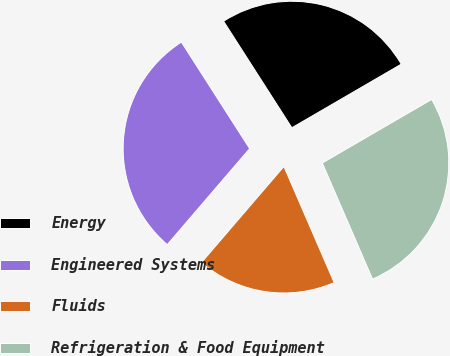<chart> <loc_0><loc_0><loc_500><loc_500><pie_chart><fcel>Energy<fcel>Engineered Systems<fcel>Fluids<fcel>Refrigeration & Food Equipment<nl><fcel>25.69%<fcel>29.64%<fcel>17.79%<fcel>26.88%<nl></chart> 